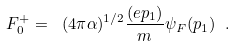Convert formula to latex. <formula><loc_0><loc_0><loc_500><loc_500>F ^ { + } _ { 0 } = \ ( 4 \pi \alpha ) ^ { 1 / 2 } \frac { ( e p _ { 1 } ) } m \psi _ { F } ( p _ { 1 } ) \ .</formula> 